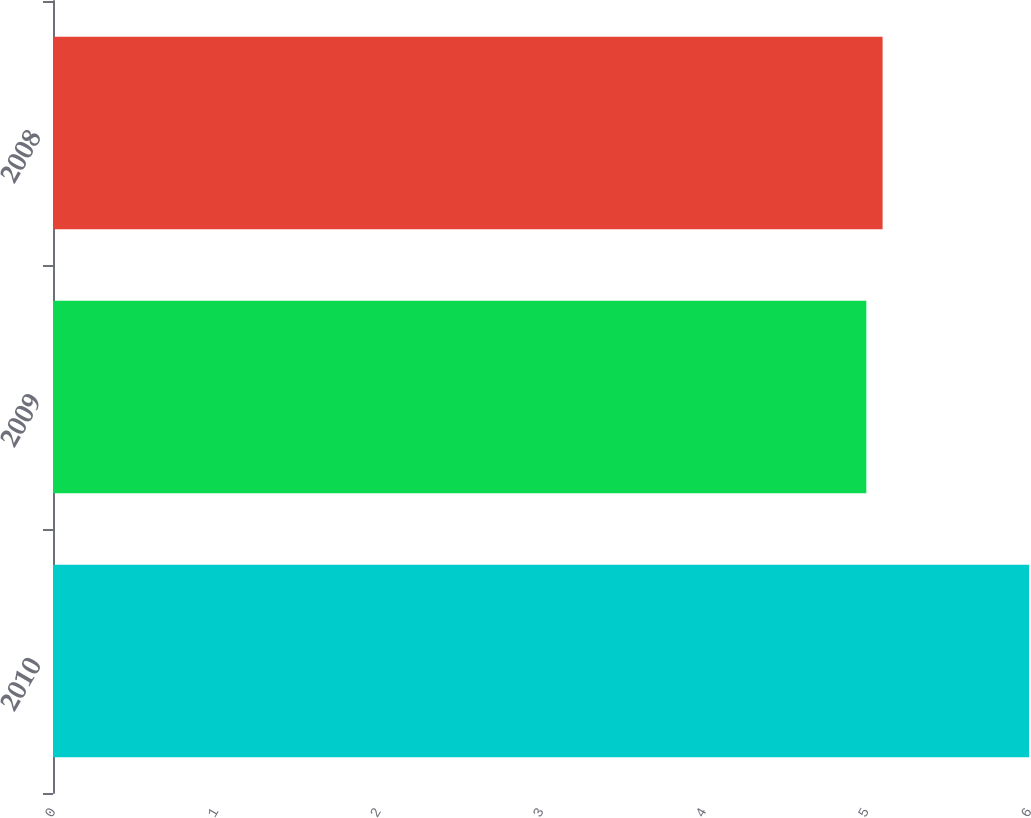Convert chart. <chart><loc_0><loc_0><loc_500><loc_500><bar_chart><fcel>2010<fcel>2009<fcel>2008<nl><fcel>6<fcel>5<fcel>5.1<nl></chart> 